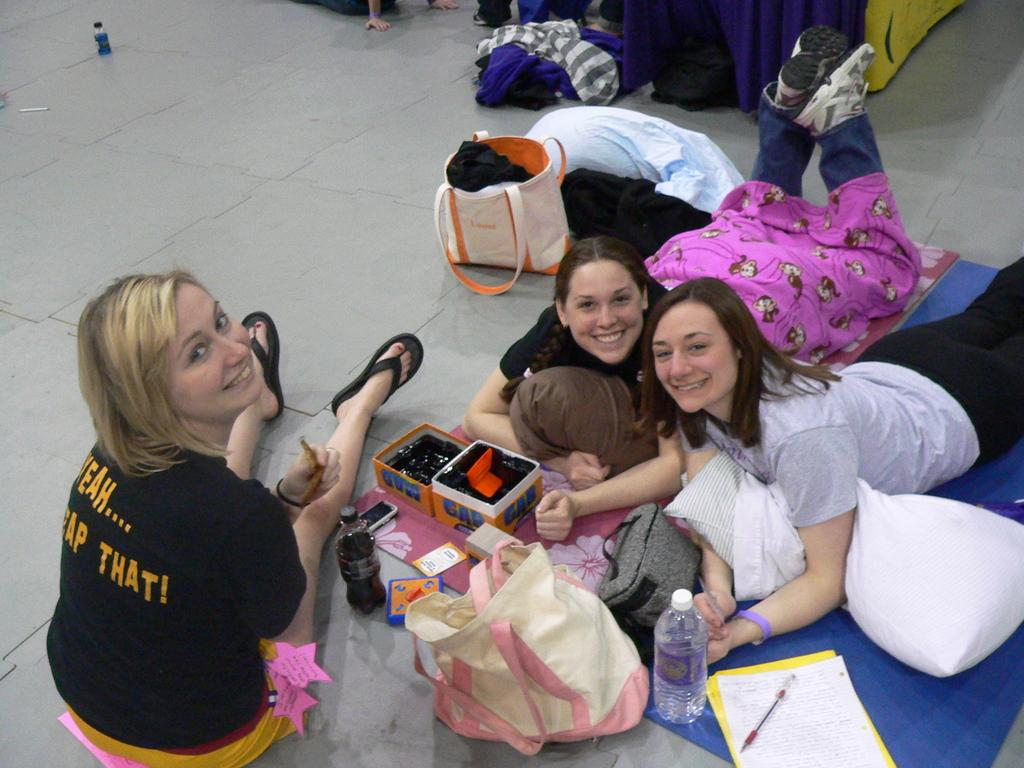<image>
Give a short and clear explanation of the subsequent image. A blonde woman has Yeah... written upon her shirt. 